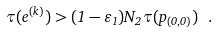Convert formula to latex. <formula><loc_0><loc_0><loc_500><loc_500>\tau ( e ^ { ( k ) } ) > ( 1 - \varepsilon _ { 1 } ) N _ { 2 } \tau ( p _ { ( 0 , 0 ) } ) \ .</formula> 